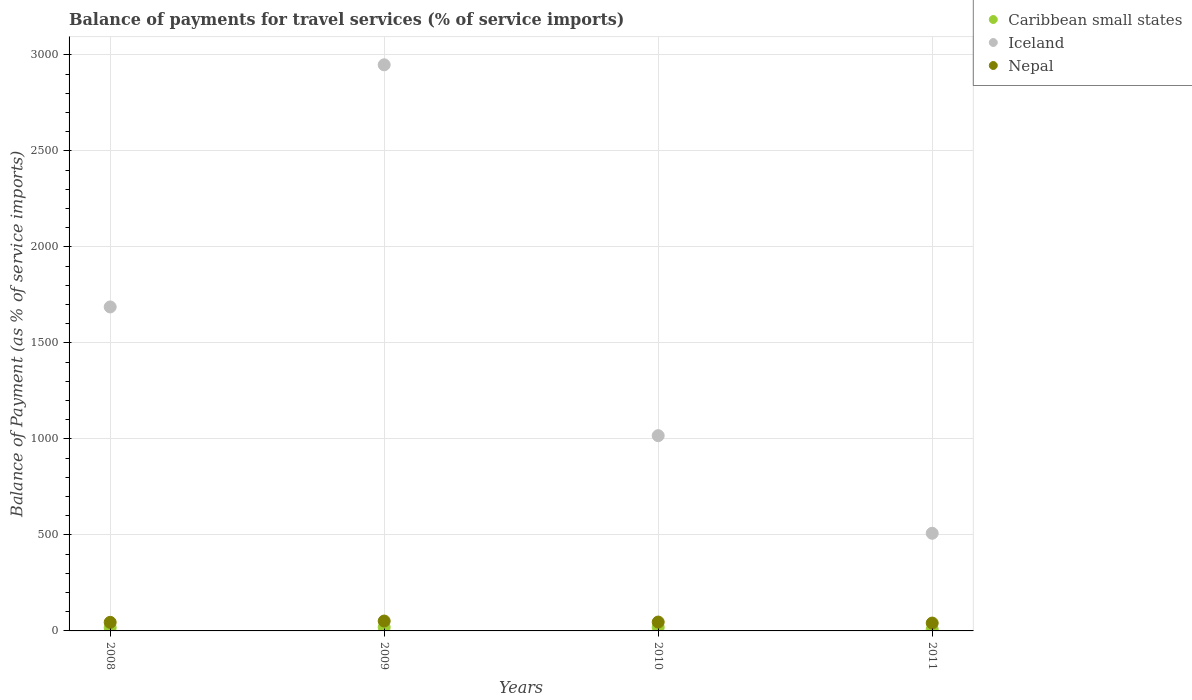How many different coloured dotlines are there?
Ensure brevity in your answer.  3. What is the balance of payments for travel services in Nepal in 2008?
Provide a succinct answer. 44.7. Across all years, what is the maximum balance of payments for travel services in Nepal?
Ensure brevity in your answer.  51.51. Across all years, what is the minimum balance of payments for travel services in Caribbean small states?
Ensure brevity in your answer.  8.17. In which year was the balance of payments for travel services in Nepal maximum?
Provide a short and direct response. 2009. In which year was the balance of payments for travel services in Iceland minimum?
Keep it short and to the point. 2011. What is the total balance of payments for travel services in Iceland in the graph?
Provide a succinct answer. 6162.01. What is the difference between the balance of payments for travel services in Caribbean small states in 2008 and that in 2009?
Make the answer very short. -1.55. What is the difference between the balance of payments for travel services in Iceland in 2011 and the balance of payments for travel services in Nepal in 2009?
Your response must be concise. 457.1. What is the average balance of payments for travel services in Caribbean small states per year?
Your answer should be compact. 15.61. In the year 2010, what is the difference between the balance of payments for travel services in Caribbean small states and balance of payments for travel services in Nepal?
Your response must be concise. -27.5. What is the ratio of the balance of payments for travel services in Iceland in 2008 to that in 2010?
Ensure brevity in your answer.  1.66. Is the balance of payments for travel services in Iceland in 2008 less than that in 2011?
Your response must be concise. No. What is the difference between the highest and the second highest balance of payments for travel services in Caribbean small states?
Your response must be concise. 0.13. What is the difference between the highest and the lowest balance of payments for travel services in Caribbean small states?
Your answer should be compact. 10.53. Is the balance of payments for travel services in Nepal strictly less than the balance of payments for travel services in Iceland over the years?
Your answer should be compact. Yes. Does the graph contain grids?
Ensure brevity in your answer.  Yes. How many legend labels are there?
Provide a short and direct response. 3. What is the title of the graph?
Ensure brevity in your answer.  Balance of payments for travel services (% of service imports). What is the label or title of the X-axis?
Keep it short and to the point. Years. What is the label or title of the Y-axis?
Your answer should be very brief. Balance of Payment (as % of service imports). What is the Balance of Payment (as % of service imports) of Caribbean small states in 2008?
Offer a terse response. 17.02. What is the Balance of Payment (as % of service imports) in Iceland in 2008?
Offer a terse response. 1687.56. What is the Balance of Payment (as % of service imports) of Nepal in 2008?
Give a very brief answer. 44.7. What is the Balance of Payment (as % of service imports) of Caribbean small states in 2009?
Ensure brevity in your answer.  18.57. What is the Balance of Payment (as % of service imports) of Iceland in 2009?
Provide a short and direct response. 2948.8. What is the Balance of Payment (as % of service imports) of Nepal in 2009?
Your answer should be compact. 51.51. What is the Balance of Payment (as % of service imports) in Caribbean small states in 2010?
Your response must be concise. 18.7. What is the Balance of Payment (as % of service imports) of Iceland in 2010?
Provide a succinct answer. 1017.05. What is the Balance of Payment (as % of service imports) of Nepal in 2010?
Give a very brief answer. 46.19. What is the Balance of Payment (as % of service imports) in Caribbean small states in 2011?
Offer a very short reply. 8.17. What is the Balance of Payment (as % of service imports) of Iceland in 2011?
Make the answer very short. 508.61. What is the Balance of Payment (as % of service imports) in Nepal in 2011?
Your response must be concise. 40.93. Across all years, what is the maximum Balance of Payment (as % of service imports) in Caribbean small states?
Give a very brief answer. 18.7. Across all years, what is the maximum Balance of Payment (as % of service imports) in Iceland?
Your answer should be very brief. 2948.8. Across all years, what is the maximum Balance of Payment (as % of service imports) of Nepal?
Your answer should be very brief. 51.51. Across all years, what is the minimum Balance of Payment (as % of service imports) of Caribbean small states?
Provide a short and direct response. 8.17. Across all years, what is the minimum Balance of Payment (as % of service imports) in Iceland?
Provide a succinct answer. 508.61. Across all years, what is the minimum Balance of Payment (as % of service imports) of Nepal?
Give a very brief answer. 40.93. What is the total Balance of Payment (as % of service imports) in Caribbean small states in the graph?
Offer a terse response. 62.46. What is the total Balance of Payment (as % of service imports) in Iceland in the graph?
Provide a short and direct response. 6162.01. What is the total Balance of Payment (as % of service imports) of Nepal in the graph?
Provide a succinct answer. 183.33. What is the difference between the Balance of Payment (as % of service imports) of Caribbean small states in 2008 and that in 2009?
Provide a succinct answer. -1.55. What is the difference between the Balance of Payment (as % of service imports) in Iceland in 2008 and that in 2009?
Provide a short and direct response. -1261.23. What is the difference between the Balance of Payment (as % of service imports) of Nepal in 2008 and that in 2009?
Your answer should be compact. -6.81. What is the difference between the Balance of Payment (as % of service imports) in Caribbean small states in 2008 and that in 2010?
Offer a terse response. -1.68. What is the difference between the Balance of Payment (as % of service imports) in Iceland in 2008 and that in 2010?
Keep it short and to the point. 670.52. What is the difference between the Balance of Payment (as % of service imports) of Nepal in 2008 and that in 2010?
Your response must be concise. -1.49. What is the difference between the Balance of Payment (as % of service imports) in Caribbean small states in 2008 and that in 2011?
Provide a succinct answer. 8.85. What is the difference between the Balance of Payment (as % of service imports) in Iceland in 2008 and that in 2011?
Offer a terse response. 1178.95. What is the difference between the Balance of Payment (as % of service imports) in Nepal in 2008 and that in 2011?
Ensure brevity in your answer.  3.77. What is the difference between the Balance of Payment (as % of service imports) of Caribbean small states in 2009 and that in 2010?
Provide a short and direct response. -0.13. What is the difference between the Balance of Payment (as % of service imports) of Iceland in 2009 and that in 2010?
Your response must be concise. 1931.75. What is the difference between the Balance of Payment (as % of service imports) in Nepal in 2009 and that in 2010?
Offer a very short reply. 5.32. What is the difference between the Balance of Payment (as % of service imports) in Caribbean small states in 2009 and that in 2011?
Your answer should be compact. 10.4. What is the difference between the Balance of Payment (as % of service imports) in Iceland in 2009 and that in 2011?
Keep it short and to the point. 2440.18. What is the difference between the Balance of Payment (as % of service imports) in Nepal in 2009 and that in 2011?
Offer a very short reply. 10.59. What is the difference between the Balance of Payment (as % of service imports) of Caribbean small states in 2010 and that in 2011?
Your answer should be very brief. 10.53. What is the difference between the Balance of Payment (as % of service imports) of Iceland in 2010 and that in 2011?
Your answer should be very brief. 508.44. What is the difference between the Balance of Payment (as % of service imports) of Nepal in 2010 and that in 2011?
Offer a terse response. 5.27. What is the difference between the Balance of Payment (as % of service imports) in Caribbean small states in 2008 and the Balance of Payment (as % of service imports) in Iceland in 2009?
Keep it short and to the point. -2931.78. What is the difference between the Balance of Payment (as % of service imports) of Caribbean small states in 2008 and the Balance of Payment (as % of service imports) of Nepal in 2009?
Give a very brief answer. -34.49. What is the difference between the Balance of Payment (as % of service imports) in Iceland in 2008 and the Balance of Payment (as % of service imports) in Nepal in 2009?
Offer a terse response. 1636.05. What is the difference between the Balance of Payment (as % of service imports) of Caribbean small states in 2008 and the Balance of Payment (as % of service imports) of Iceland in 2010?
Offer a very short reply. -1000.03. What is the difference between the Balance of Payment (as % of service imports) of Caribbean small states in 2008 and the Balance of Payment (as % of service imports) of Nepal in 2010?
Offer a terse response. -29.18. What is the difference between the Balance of Payment (as % of service imports) in Iceland in 2008 and the Balance of Payment (as % of service imports) in Nepal in 2010?
Your answer should be compact. 1641.37. What is the difference between the Balance of Payment (as % of service imports) of Caribbean small states in 2008 and the Balance of Payment (as % of service imports) of Iceland in 2011?
Your answer should be compact. -491.59. What is the difference between the Balance of Payment (as % of service imports) in Caribbean small states in 2008 and the Balance of Payment (as % of service imports) in Nepal in 2011?
Your answer should be compact. -23.91. What is the difference between the Balance of Payment (as % of service imports) of Iceland in 2008 and the Balance of Payment (as % of service imports) of Nepal in 2011?
Your answer should be compact. 1646.64. What is the difference between the Balance of Payment (as % of service imports) in Caribbean small states in 2009 and the Balance of Payment (as % of service imports) in Iceland in 2010?
Give a very brief answer. -998.48. What is the difference between the Balance of Payment (as % of service imports) in Caribbean small states in 2009 and the Balance of Payment (as % of service imports) in Nepal in 2010?
Make the answer very short. -27.62. What is the difference between the Balance of Payment (as % of service imports) in Iceland in 2009 and the Balance of Payment (as % of service imports) in Nepal in 2010?
Your response must be concise. 2902.6. What is the difference between the Balance of Payment (as % of service imports) in Caribbean small states in 2009 and the Balance of Payment (as % of service imports) in Iceland in 2011?
Ensure brevity in your answer.  -490.04. What is the difference between the Balance of Payment (as % of service imports) in Caribbean small states in 2009 and the Balance of Payment (as % of service imports) in Nepal in 2011?
Ensure brevity in your answer.  -22.36. What is the difference between the Balance of Payment (as % of service imports) of Iceland in 2009 and the Balance of Payment (as % of service imports) of Nepal in 2011?
Offer a very short reply. 2907.87. What is the difference between the Balance of Payment (as % of service imports) of Caribbean small states in 2010 and the Balance of Payment (as % of service imports) of Iceland in 2011?
Give a very brief answer. -489.91. What is the difference between the Balance of Payment (as % of service imports) of Caribbean small states in 2010 and the Balance of Payment (as % of service imports) of Nepal in 2011?
Give a very brief answer. -22.23. What is the difference between the Balance of Payment (as % of service imports) of Iceland in 2010 and the Balance of Payment (as % of service imports) of Nepal in 2011?
Make the answer very short. 976.12. What is the average Balance of Payment (as % of service imports) of Caribbean small states per year?
Keep it short and to the point. 15.61. What is the average Balance of Payment (as % of service imports) in Iceland per year?
Make the answer very short. 1540.5. What is the average Balance of Payment (as % of service imports) in Nepal per year?
Ensure brevity in your answer.  45.83. In the year 2008, what is the difference between the Balance of Payment (as % of service imports) in Caribbean small states and Balance of Payment (as % of service imports) in Iceland?
Your answer should be compact. -1670.54. In the year 2008, what is the difference between the Balance of Payment (as % of service imports) of Caribbean small states and Balance of Payment (as % of service imports) of Nepal?
Offer a terse response. -27.68. In the year 2008, what is the difference between the Balance of Payment (as % of service imports) in Iceland and Balance of Payment (as % of service imports) in Nepal?
Give a very brief answer. 1642.86. In the year 2009, what is the difference between the Balance of Payment (as % of service imports) of Caribbean small states and Balance of Payment (as % of service imports) of Iceland?
Give a very brief answer. -2930.23. In the year 2009, what is the difference between the Balance of Payment (as % of service imports) of Caribbean small states and Balance of Payment (as % of service imports) of Nepal?
Provide a succinct answer. -32.94. In the year 2009, what is the difference between the Balance of Payment (as % of service imports) of Iceland and Balance of Payment (as % of service imports) of Nepal?
Keep it short and to the point. 2897.28. In the year 2010, what is the difference between the Balance of Payment (as % of service imports) of Caribbean small states and Balance of Payment (as % of service imports) of Iceland?
Your response must be concise. -998.35. In the year 2010, what is the difference between the Balance of Payment (as % of service imports) of Caribbean small states and Balance of Payment (as % of service imports) of Nepal?
Offer a terse response. -27.5. In the year 2010, what is the difference between the Balance of Payment (as % of service imports) in Iceland and Balance of Payment (as % of service imports) in Nepal?
Your response must be concise. 970.85. In the year 2011, what is the difference between the Balance of Payment (as % of service imports) of Caribbean small states and Balance of Payment (as % of service imports) of Iceland?
Your answer should be very brief. -500.44. In the year 2011, what is the difference between the Balance of Payment (as % of service imports) in Caribbean small states and Balance of Payment (as % of service imports) in Nepal?
Your response must be concise. -32.76. In the year 2011, what is the difference between the Balance of Payment (as % of service imports) in Iceland and Balance of Payment (as % of service imports) in Nepal?
Provide a succinct answer. 467.69. What is the ratio of the Balance of Payment (as % of service imports) of Caribbean small states in 2008 to that in 2009?
Make the answer very short. 0.92. What is the ratio of the Balance of Payment (as % of service imports) in Iceland in 2008 to that in 2009?
Offer a very short reply. 0.57. What is the ratio of the Balance of Payment (as % of service imports) of Nepal in 2008 to that in 2009?
Your answer should be compact. 0.87. What is the ratio of the Balance of Payment (as % of service imports) in Caribbean small states in 2008 to that in 2010?
Your answer should be compact. 0.91. What is the ratio of the Balance of Payment (as % of service imports) in Iceland in 2008 to that in 2010?
Offer a very short reply. 1.66. What is the ratio of the Balance of Payment (as % of service imports) in Caribbean small states in 2008 to that in 2011?
Make the answer very short. 2.08. What is the ratio of the Balance of Payment (as % of service imports) in Iceland in 2008 to that in 2011?
Your answer should be compact. 3.32. What is the ratio of the Balance of Payment (as % of service imports) of Nepal in 2008 to that in 2011?
Offer a terse response. 1.09. What is the ratio of the Balance of Payment (as % of service imports) of Iceland in 2009 to that in 2010?
Your answer should be very brief. 2.9. What is the ratio of the Balance of Payment (as % of service imports) in Nepal in 2009 to that in 2010?
Make the answer very short. 1.12. What is the ratio of the Balance of Payment (as % of service imports) of Caribbean small states in 2009 to that in 2011?
Your answer should be very brief. 2.27. What is the ratio of the Balance of Payment (as % of service imports) in Iceland in 2009 to that in 2011?
Offer a very short reply. 5.8. What is the ratio of the Balance of Payment (as % of service imports) of Nepal in 2009 to that in 2011?
Offer a terse response. 1.26. What is the ratio of the Balance of Payment (as % of service imports) in Caribbean small states in 2010 to that in 2011?
Provide a short and direct response. 2.29. What is the ratio of the Balance of Payment (as % of service imports) in Iceland in 2010 to that in 2011?
Ensure brevity in your answer.  2. What is the ratio of the Balance of Payment (as % of service imports) in Nepal in 2010 to that in 2011?
Your answer should be very brief. 1.13. What is the difference between the highest and the second highest Balance of Payment (as % of service imports) in Caribbean small states?
Offer a very short reply. 0.13. What is the difference between the highest and the second highest Balance of Payment (as % of service imports) of Iceland?
Offer a terse response. 1261.23. What is the difference between the highest and the second highest Balance of Payment (as % of service imports) of Nepal?
Provide a short and direct response. 5.32. What is the difference between the highest and the lowest Balance of Payment (as % of service imports) in Caribbean small states?
Your answer should be very brief. 10.53. What is the difference between the highest and the lowest Balance of Payment (as % of service imports) of Iceland?
Ensure brevity in your answer.  2440.18. What is the difference between the highest and the lowest Balance of Payment (as % of service imports) in Nepal?
Provide a short and direct response. 10.59. 